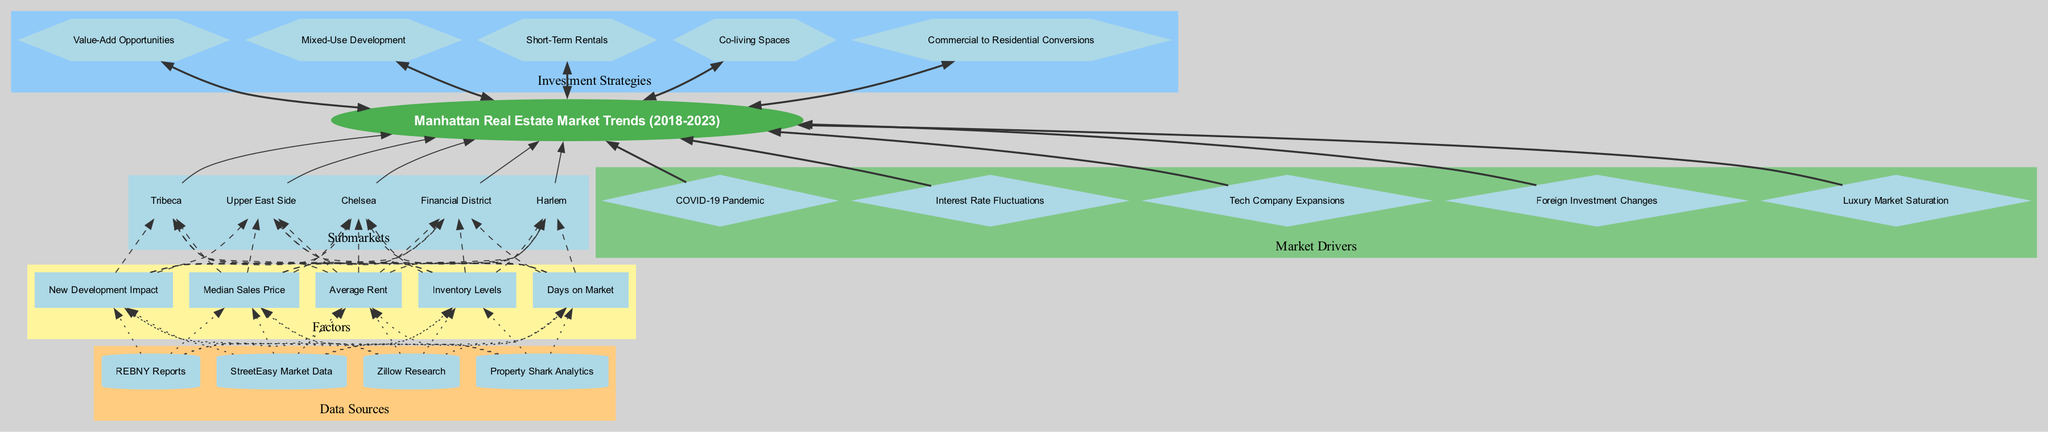What is the root of the diagram? The root node indicates the main focus of the diagram, which is derived directly from the title given at the beginning. In this case, the root node is labeled "Manhattan Real Estate Market Trends (2018-2023)."
Answer: Manhattan Real Estate Market Trends (2018-2023) How many submarkets are represented in the diagram? By counting the submarket nodes listed under the "Submarkets" cluster, there are five distinct submarkets mentioned, indicating the diversity in the areas being analyzed.
Answer: 5 What factor has a dashed edge to the Upper East Side submarket? The factor nodes are linked with dashed edges to the submarkets, showing the relationship between factors and submarkets. By examining the edges connected to 'Upper East Side,' we can see that "Median Sales Price" connects to it.
Answer: Median Sales Price List two data sources in the diagram. The data sources are grouped in a cluster with each represented by a cylinder node. By reviewing the names listed under this cluster, we can find "REBNY Reports" and "StreetEasy Market Data" as examples.
Answer: REBNY Reports, StreetEasy Market Data Which market driver is set apart by a diamond shape? The market drivers appear as diamond-shaped nodes indicating their significant role in influencing the real estate market trends. Among them, "COVID-19 Pandemic" is one such driver in the diagram.
Answer: COVID-19 Pandemic What is the connection style between strategies and the main root node? The edges connecting the strategy nodes to the root are shown as bold and directed in both ways, indicating a mutual relationship or importance of these strategies in the context of the root topic.
Answer: Bold How many investment strategies are listed in the diagram? Similar to the submarkets, by counting the unique hexagon-shaped nodes in the "Investment Strategies" cluster, we identify that there are five investment strategies presented.
Answer: 5 Which data source links to "Days on Market"? To find this, we recognize that the "Days on Market" factor node has dotted edges connected to the data sources, and tracing these connections leads us to identify that "Property Shark Analytics" is one such link.
Answer: Property Shark Analytics What does the "Mixed-Use Development" strategy relate to in the overall market context? Analyzing the edge connections that link back to the root shows that "Mixed-Use Development" relates directly to trends in the Manhattan real estate market, indicating its relevance in investment strategies.
Answer: Manhattan Real Estate Market Trends (2018-2023) 